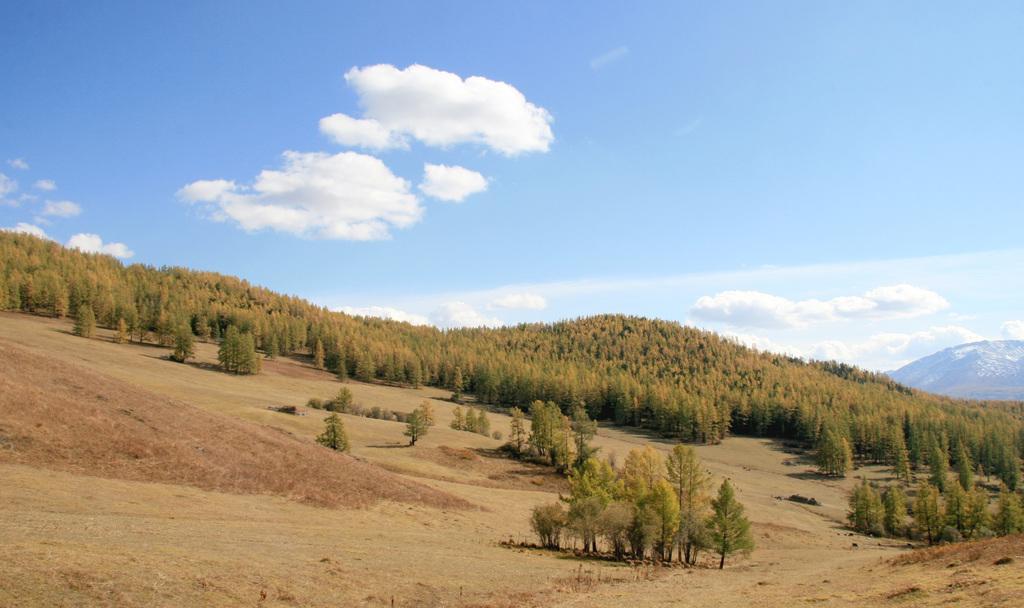Could you give a brief overview of what you see in this image? At the bottom of the picture, we see grass. There are trees in the background. At the top of the picture, we see the sky and the clouds. On the right side of the picture, we see a hill. 